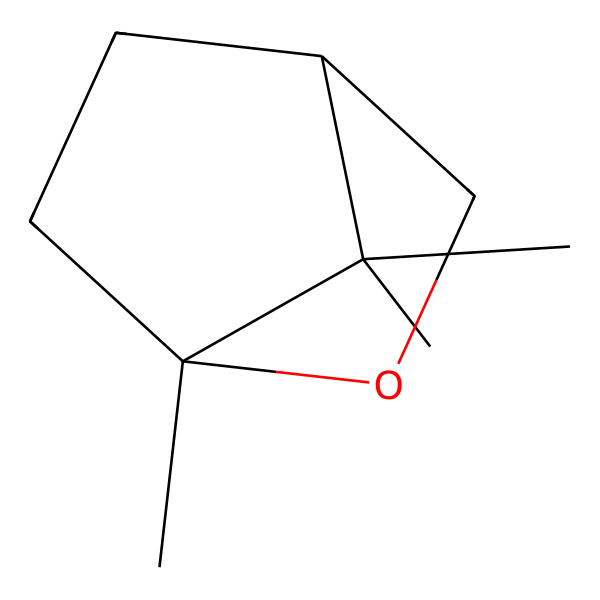What is the name of the chemical based on the SMILES provided? The provided SMILES corresponds to a ring structure commonly associated with eucalyptol, which is derived from eucalyptus.
Answer: eucalyptol How many carbon atoms are present in this chemical structure? Analyzing the SMILES representation, we can count a total of 10 carbon atoms in the structure, including the branched and ring components.
Answer: 10 What type of cyclic structure is present in this chemical? The chemical is a cycloalkane since it consists of carbon atoms arranged in a ring with single bonds only.
Answer: cycloalkane What functional group is indicated in the structure of this chemical? The presence of an oxygen atom in the structure suggests that this chemical contains an ether functional group, represented by the -O- bond connecting the two carbons.
Answer: ether How many rings are present in the structure of eucalyptol? The analysis of the structure indicates that there are two rings in the eucalyptol chemical, forming a bicyclic compound.
Answer: two 